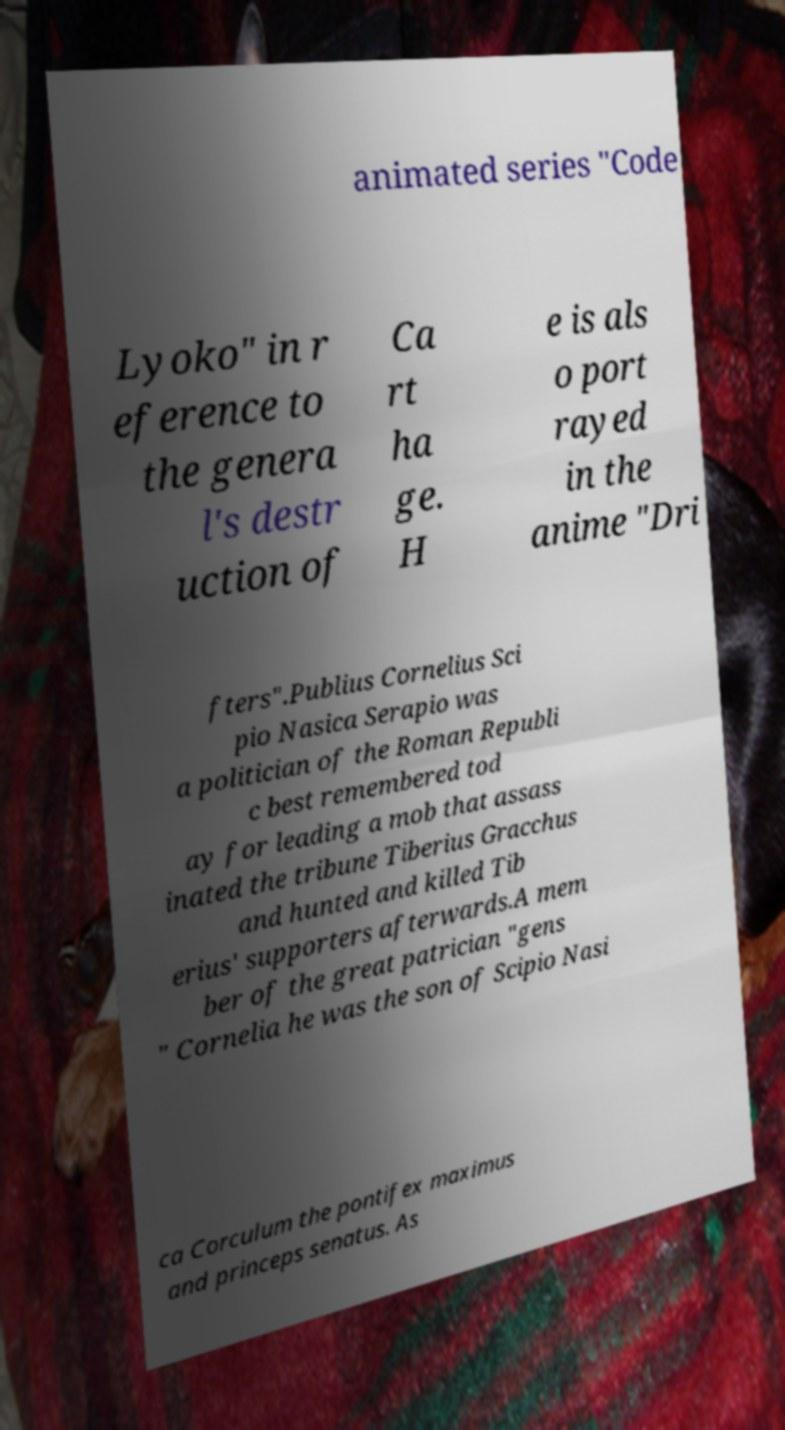I need the written content from this picture converted into text. Can you do that? animated series "Code Lyoko" in r eference to the genera l's destr uction of Ca rt ha ge. H e is als o port rayed in the anime "Dri fters".Publius Cornelius Sci pio Nasica Serapio was a politician of the Roman Republi c best remembered tod ay for leading a mob that assass inated the tribune Tiberius Gracchus and hunted and killed Tib erius' supporters afterwards.A mem ber of the great patrician "gens " Cornelia he was the son of Scipio Nasi ca Corculum the pontifex maximus and princeps senatus. As 